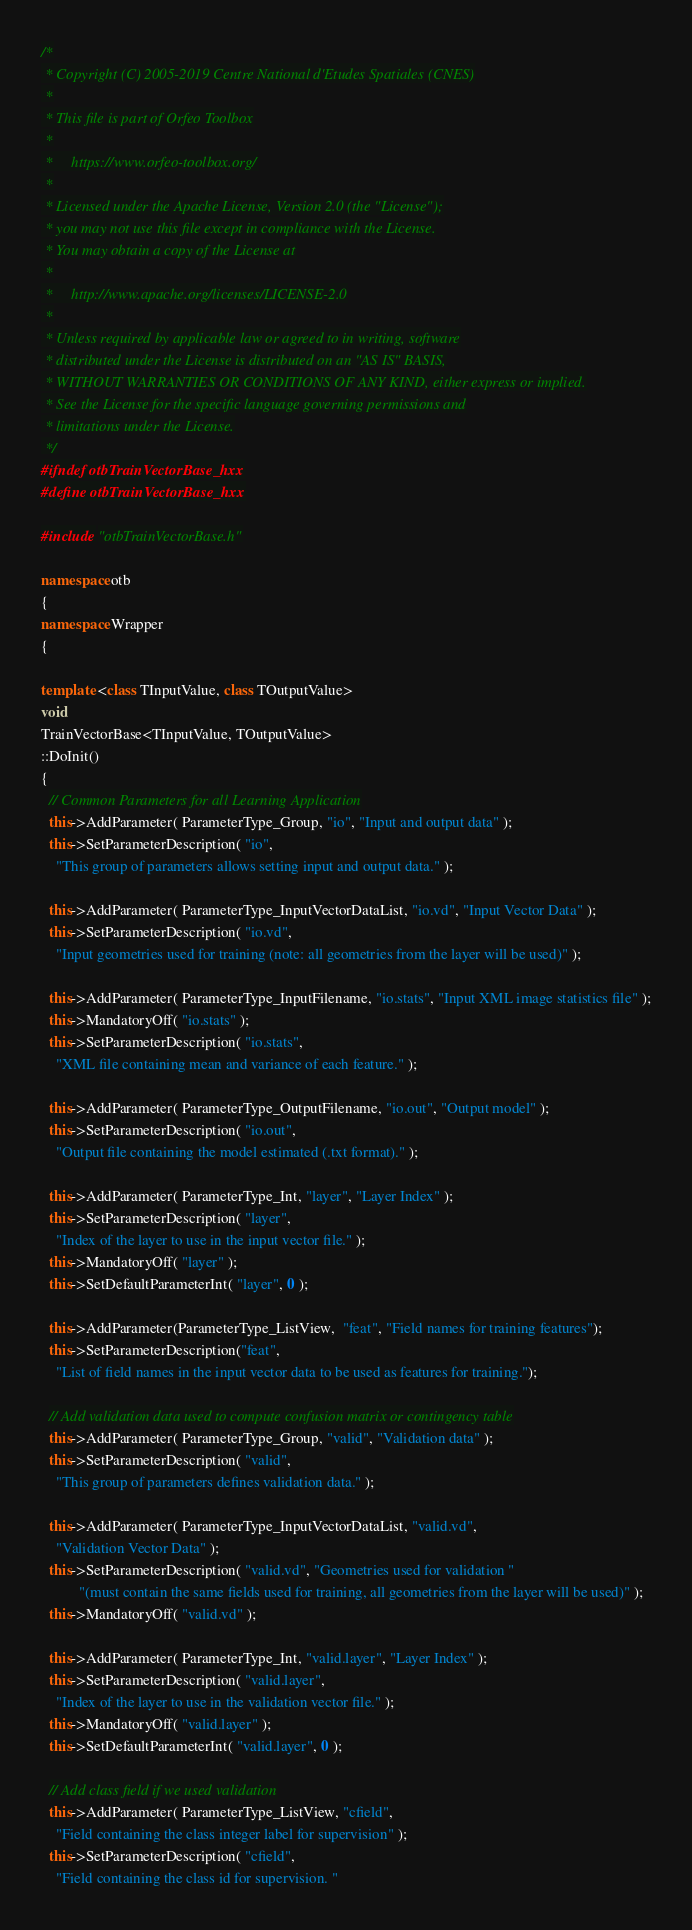<code> <loc_0><loc_0><loc_500><loc_500><_C++_>/*
 * Copyright (C) 2005-2019 Centre National d'Etudes Spatiales (CNES)
 *
 * This file is part of Orfeo Toolbox
 *
 *     https://www.orfeo-toolbox.org/
 *
 * Licensed under the Apache License, Version 2.0 (the "License");
 * you may not use this file except in compliance with the License.
 * You may obtain a copy of the License at
 *
 *     http://www.apache.org/licenses/LICENSE-2.0
 *
 * Unless required by applicable law or agreed to in writing, software
 * distributed under the License is distributed on an "AS IS" BASIS,
 * WITHOUT WARRANTIES OR CONDITIONS OF ANY KIND, either express or implied.
 * See the License for the specific language governing permissions and
 * limitations under the License.
 */
#ifndef otbTrainVectorBase_hxx
#define otbTrainVectorBase_hxx

#include "otbTrainVectorBase.h"

namespace otb
{
namespace Wrapper
{

template <class TInputValue, class TOutputValue>
void
TrainVectorBase<TInputValue, TOutputValue>
::DoInit()
{
  // Common Parameters for all Learning Application
  this->AddParameter( ParameterType_Group, "io", "Input and output data" );
  this->SetParameterDescription( "io", 
    "This group of parameters allows setting input and output data." );

  this->AddParameter( ParameterType_InputVectorDataList, "io.vd", "Input Vector Data" );
  this->SetParameterDescription( "io.vd",
    "Input geometries used for training (note: all geometries from the layer will be used)" );

  this->AddParameter( ParameterType_InputFilename, "io.stats", "Input XML image statistics file" );
  this->MandatoryOff( "io.stats" );
  this->SetParameterDescription( "io.stats", 
    "XML file containing mean and variance of each feature." );

  this->AddParameter( ParameterType_OutputFilename, "io.out", "Output model" );
  this->SetParameterDescription( "io.out", 
    "Output file containing the model estimated (.txt format)." );

  this->AddParameter( ParameterType_Int, "layer", "Layer Index" );
  this->SetParameterDescription( "layer", 
    "Index of the layer to use in the input vector file." );
  this->MandatoryOff( "layer" );
  this->SetDefaultParameterInt( "layer", 0 );

  this->AddParameter(ParameterType_ListView,  "feat", "Field names for training features");
  this->SetParameterDescription("feat",
    "List of field names in the input vector data to be used as features for training.");

  // Add validation data used to compute confusion matrix or contingency table
  this->AddParameter( ParameterType_Group, "valid", "Validation data" );
  this->SetParameterDescription( "valid", 
    "This group of parameters defines validation data." );

  this->AddParameter( ParameterType_InputVectorDataList, "valid.vd", 
    "Validation Vector Data" );
  this->SetParameterDescription( "valid.vd", "Geometries used for validation "
          "(must contain the same fields used for training, all geometries from the layer will be used)" );
  this->MandatoryOff( "valid.vd" );

  this->AddParameter( ParameterType_Int, "valid.layer", "Layer Index" );
  this->SetParameterDescription( "valid.layer", 
    "Index of the layer to use in the validation vector file." );
  this->MandatoryOff( "valid.layer" );
  this->SetDefaultParameterInt( "valid.layer", 0 );

  // Add class field if we used validation
  this->AddParameter( ParameterType_ListView, "cfield",
    "Field containing the class integer label for supervision" );
  this->SetParameterDescription( "cfield", 
    "Field containing the class id for supervision. "</code> 